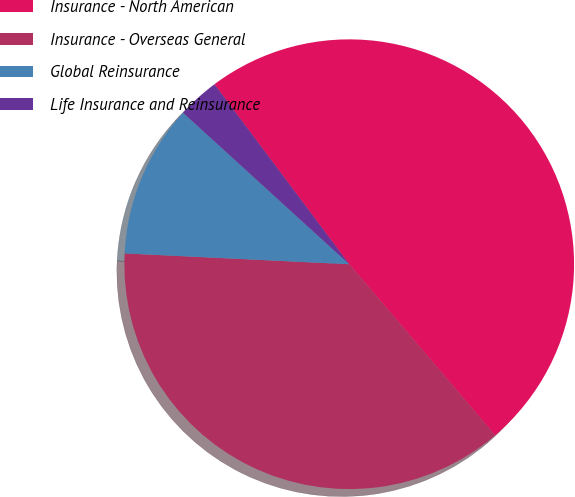<chart> <loc_0><loc_0><loc_500><loc_500><pie_chart><fcel>Insurance - North American<fcel>Insurance - Overseas General<fcel>Global Reinsurance<fcel>Life Insurance and Reinsurance<nl><fcel>49.0%<fcel>37.0%<fcel>11.0%<fcel>3.0%<nl></chart> 